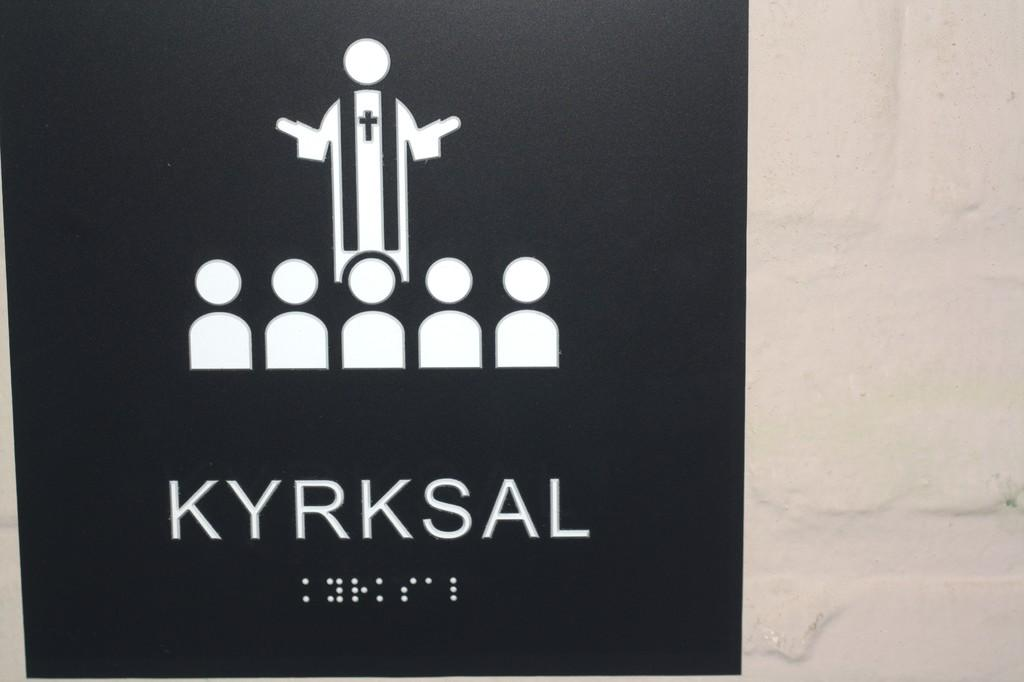<image>
Render a clear and concise summary of the photo. Black background with the word KRYKSAL in white letters. 